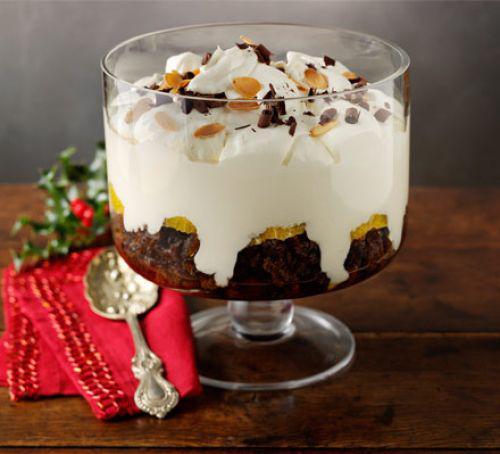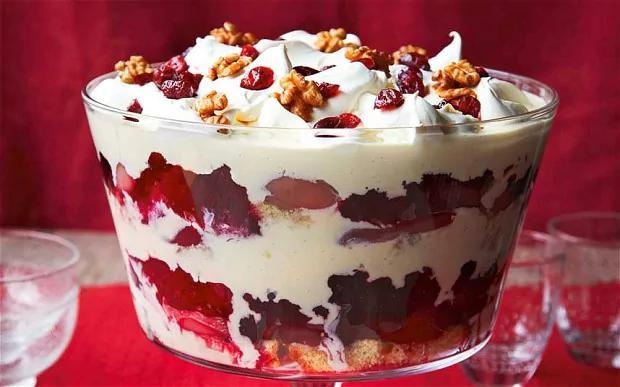The first image is the image on the left, the second image is the image on the right. Considering the images on both sides, is "There are two servings of desserts in the image on the right." valid? Answer yes or no. No. 